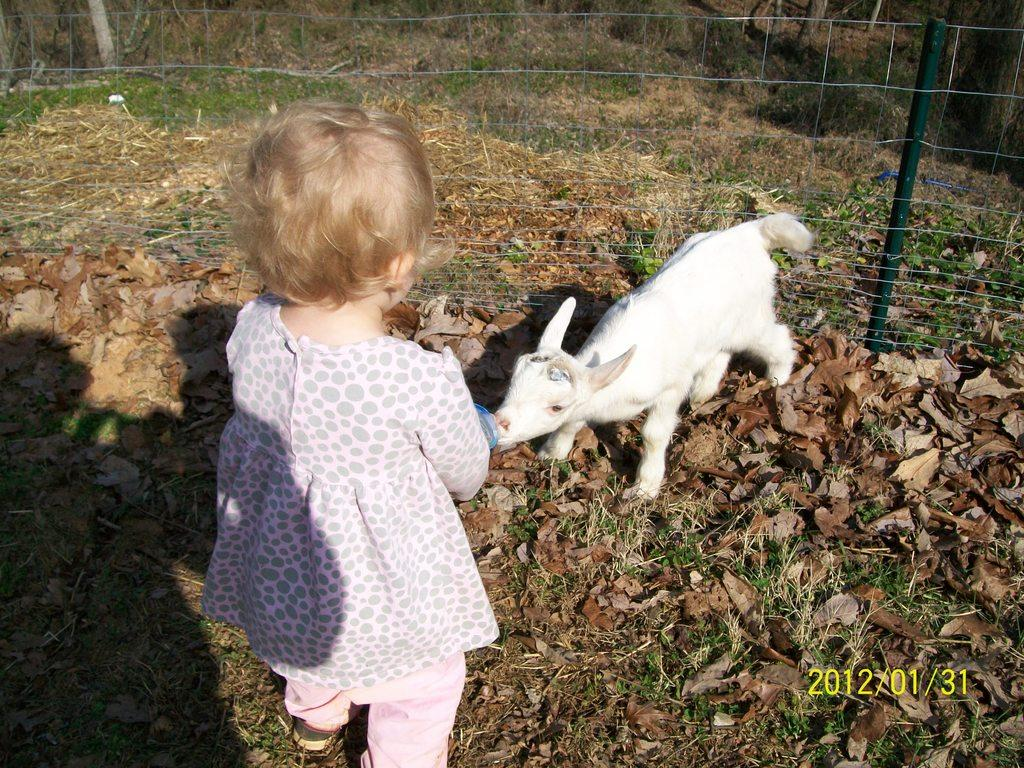What type of animal is in the image? There is an animal in the image, but the specific type cannot be determined from the provided facts. Who is also present in the image? There is a child in the image. What can be seen in the background of the image? There is a fence in the image. What is the condition of the grass in the image? Dried leaves are present on the grass in the image. What additional information is provided at the bottom right corner of the image? There is a date at the bottom right corner of the image. What type of cloth is covering the goat in the image? There is no goat present in the image, and therefore no cloth covering a goat. 